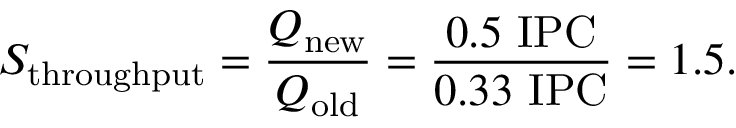Convert formula to latex. <formula><loc_0><loc_0><loc_500><loc_500>S _ { t h r o u g h p u t } = { \frac { Q _ { n e w } } { Q _ { o l d } } } = { \frac { 0 . 5 { I P C } } { 0 . 3 3 { I P C } } } = 1 . 5 .</formula> 